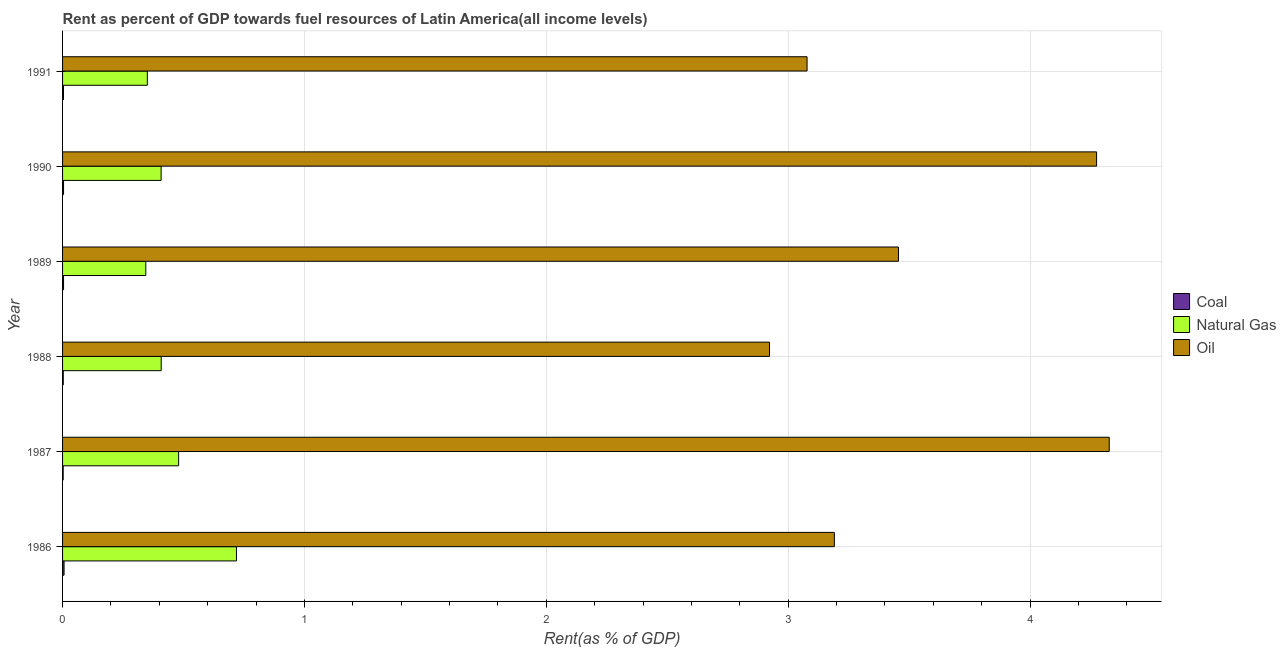How many groups of bars are there?
Provide a short and direct response. 6. Are the number of bars on each tick of the Y-axis equal?
Ensure brevity in your answer.  Yes. How many bars are there on the 6th tick from the top?
Your answer should be compact. 3. What is the label of the 5th group of bars from the top?
Provide a succinct answer. 1987. In how many cases, is the number of bars for a given year not equal to the number of legend labels?
Keep it short and to the point. 0. What is the rent towards natural gas in 1987?
Keep it short and to the point. 0.48. Across all years, what is the maximum rent towards oil?
Provide a short and direct response. 4.33. Across all years, what is the minimum rent towards coal?
Provide a short and direct response. 0. In which year was the rent towards oil maximum?
Your response must be concise. 1987. In which year was the rent towards natural gas minimum?
Keep it short and to the point. 1989. What is the total rent towards natural gas in the graph?
Make the answer very short. 2.71. What is the difference between the rent towards coal in 1988 and that in 1990?
Provide a short and direct response. -0. What is the difference between the rent towards coal in 1990 and the rent towards natural gas in 1987?
Make the answer very short. -0.48. What is the average rent towards natural gas per year?
Offer a terse response. 0.45. In the year 1991, what is the difference between the rent towards coal and rent towards oil?
Offer a terse response. -3.07. What is the ratio of the rent towards coal in 1987 to that in 1988?
Make the answer very short. 0.87. Is the difference between the rent towards natural gas in 1988 and 1991 greater than the difference between the rent towards coal in 1988 and 1991?
Keep it short and to the point. Yes. What is the difference between the highest and the second highest rent towards natural gas?
Your answer should be compact. 0.24. What is the difference between the highest and the lowest rent towards natural gas?
Give a very brief answer. 0.37. Is the sum of the rent towards natural gas in 1988 and 1990 greater than the maximum rent towards coal across all years?
Provide a succinct answer. Yes. What does the 2nd bar from the top in 1986 represents?
Offer a very short reply. Natural Gas. What does the 2nd bar from the bottom in 1991 represents?
Give a very brief answer. Natural Gas. Is it the case that in every year, the sum of the rent towards coal and rent towards natural gas is greater than the rent towards oil?
Give a very brief answer. No. Are all the bars in the graph horizontal?
Offer a terse response. Yes. How many years are there in the graph?
Offer a very short reply. 6. Are the values on the major ticks of X-axis written in scientific E-notation?
Provide a succinct answer. No. Does the graph contain any zero values?
Give a very brief answer. No. Does the graph contain grids?
Offer a terse response. Yes. How are the legend labels stacked?
Provide a succinct answer. Vertical. What is the title of the graph?
Your answer should be compact. Rent as percent of GDP towards fuel resources of Latin America(all income levels). Does "Grants" appear as one of the legend labels in the graph?
Offer a very short reply. No. What is the label or title of the X-axis?
Your answer should be compact. Rent(as % of GDP). What is the Rent(as % of GDP) in Coal in 1986?
Provide a succinct answer. 0.01. What is the Rent(as % of GDP) in Natural Gas in 1986?
Offer a terse response. 0.72. What is the Rent(as % of GDP) in Oil in 1986?
Ensure brevity in your answer.  3.19. What is the Rent(as % of GDP) of Coal in 1987?
Offer a very short reply. 0. What is the Rent(as % of GDP) in Natural Gas in 1987?
Give a very brief answer. 0.48. What is the Rent(as % of GDP) in Oil in 1987?
Keep it short and to the point. 4.33. What is the Rent(as % of GDP) in Coal in 1988?
Provide a succinct answer. 0. What is the Rent(as % of GDP) in Natural Gas in 1988?
Keep it short and to the point. 0.41. What is the Rent(as % of GDP) in Oil in 1988?
Offer a very short reply. 2.92. What is the Rent(as % of GDP) in Coal in 1989?
Your answer should be very brief. 0. What is the Rent(as % of GDP) of Natural Gas in 1989?
Offer a terse response. 0.34. What is the Rent(as % of GDP) of Oil in 1989?
Your answer should be compact. 3.46. What is the Rent(as % of GDP) in Coal in 1990?
Provide a short and direct response. 0. What is the Rent(as % of GDP) of Natural Gas in 1990?
Ensure brevity in your answer.  0.41. What is the Rent(as % of GDP) in Oil in 1990?
Make the answer very short. 4.28. What is the Rent(as % of GDP) in Coal in 1991?
Offer a very short reply. 0. What is the Rent(as % of GDP) of Natural Gas in 1991?
Offer a terse response. 0.35. What is the Rent(as % of GDP) in Oil in 1991?
Your answer should be very brief. 3.08. Across all years, what is the maximum Rent(as % of GDP) in Coal?
Provide a succinct answer. 0.01. Across all years, what is the maximum Rent(as % of GDP) in Natural Gas?
Keep it short and to the point. 0.72. Across all years, what is the maximum Rent(as % of GDP) of Oil?
Keep it short and to the point. 4.33. Across all years, what is the minimum Rent(as % of GDP) of Coal?
Your answer should be compact. 0. Across all years, what is the minimum Rent(as % of GDP) in Natural Gas?
Your answer should be very brief. 0.34. Across all years, what is the minimum Rent(as % of GDP) of Oil?
Provide a short and direct response. 2.92. What is the total Rent(as % of GDP) of Coal in the graph?
Your answer should be compact. 0.02. What is the total Rent(as % of GDP) in Natural Gas in the graph?
Your answer should be very brief. 2.71. What is the total Rent(as % of GDP) in Oil in the graph?
Your answer should be compact. 21.25. What is the difference between the Rent(as % of GDP) of Coal in 1986 and that in 1987?
Provide a short and direct response. 0. What is the difference between the Rent(as % of GDP) in Natural Gas in 1986 and that in 1987?
Provide a succinct answer. 0.24. What is the difference between the Rent(as % of GDP) in Oil in 1986 and that in 1987?
Provide a short and direct response. -1.14. What is the difference between the Rent(as % of GDP) of Coal in 1986 and that in 1988?
Provide a succinct answer. 0. What is the difference between the Rent(as % of GDP) in Natural Gas in 1986 and that in 1988?
Your answer should be very brief. 0.31. What is the difference between the Rent(as % of GDP) of Oil in 1986 and that in 1988?
Provide a succinct answer. 0.27. What is the difference between the Rent(as % of GDP) in Coal in 1986 and that in 1989?
Give a very brief answer. 0. What is the difference between the Rent(as % of GDP) in Natural Gas in 1986 and that in 1989?
Provide a short and direct response. 0.37. What is the difference between the Rent(as % of GDP) in Oil in 1986 and that in 1989?
Make the answer very short. -0.27. What is the difference between the Rent(as % of GDP) in Coal in 1986 and that in 1990?
Provide a succinct answer. 0. What is the difference between the Rent(as % of GDP) in Natural Gas in 1986 and that in 1990?
Offer a very short reply. 0.31. What is the difference between the Rent(as % of GDP) of Oil in 1986 and that in 1990?
Provide a short and direct response. -1.08. What is the difference between the Rent(as % of GDP) of Coal in 1986 and that in 1991?
Your answer should be compact. 0. What is the difference between the Rent(as % of GDP) of Natural Gas in 1986 and that in 1991?
Make the answer very short. 0.37. What is the difference between the Rent(as % of GDP) of Oil in 1986 and that in 1991?
Your answer should be compact. 0.11. What is the difference between the Rent(as % of GDP) of Coal in 1987 and that in 1988?
Ensure brevity in your answer.  -0. What is the difference between the Rent(as % of GDP) in Natural Gas in 1987 and that in 1988?
Give a very brief answer. 0.07. What is the difference between the Rent(as % of GDP) in Oil in 1987 and that in 1988?
Your answer should be very brief. 1.4. What is the difference between the Rent(as % of GDP) of Coal in 1987 and that in 1989?
Your response must be concise. -0. What is the difference between the Rent(as % of GDP) of Natural Gas in 1987 and that in 1989?
Your response must be concise. 0.14. What is the difference between the Rent(as % of GDP) in Oil in 1987 and that in 1989?
Your answer should be very brief. 0.87. What is the difference between the Rent(as % of GDP) in Coal in 1987 and that in 1990?
Ensure brevity in your answer.  -0. What is the difference between the Rent(as % of GDP) in Natural Gas in 1987 and that in 1990?
Your answer should be compact. 0.07. What is the difference between the Rent(as % of GDP) in Oil in 1987 and that in 1990?
Offer a terse response. 0.05. What is the difference between the Rent(as % of GDP) of Coal in 1987 and that in 1991?
Provide a short and direct response. -0. What is the difference between the Rent(as % of GDP) in Natural Gas in 1987 and that in 1991?
Offer a very short reply. 0.13. What is the difference between the Rent(as % of GDP) of Oil in 1987 and that in 1991?
Your answer should be very brief. 1.25. What is the difference between the Rent(as % of GDP) in Coal in 1988 and that in 1989?
Your response must be concise. -0. What is the difference between the Rent(as % of GDP) of Natural Gas in 1988 and that in 1989?
Provide a short and direct response. 0.06. What is the difference between the Rent(as % of GDP) in Oil in 1988 and that in 1989?
Offer a terse response. -0.53. What is the difference between the Rent(as % of GDP) in Coal in 1988 and that in 1990?
Offer a terse response. -0. What is the difference between the Rent(as % of GDP) of Natural Gas in 1988 and that in 1990?
Make the answer very short. 0. What is the difference between the Rent(as % of GDP) of Oil in 1988 and that in 1990?
Your answer should be compact. -1.35. What is the difference between the Rent(as % of GDP) of Coal in 1988 and that in 1991?
Offer a very short reply. -0. What is the difference between the Rent(as % of GDP) in Natural Gas in 1988 and that in 1991?
Provide a succinct answer. 0.06. What is the difference between the Rent(as % of GDP) in Oil in 1988 and that in 1991?
Keep it short and to the point. -0.16. What is the difference between the Rent(as % of GDP) of Natural Gas in 1989 and that in 1990?
Keep it short and to the point. -0.06. What is the difference between the Rent(as % of GDP) in Oil in 1989 and that in 1990?
Your answer should be compact. -0.82. What is the difference between the Rent(as % of GDP) in Natural Gas in 1989 and that in 1991?
Offer a very short reply. -0.01. What is the difference between the Rent(as % of GDP) of Oil in 1989 and that in 1991?
Ensure brevity in your answer.  0.38. What is the difference between the Rent(as % of GDP) of Natural Gas in 1990 and that in 1991?
Offer a terse response. 0.06. What is the difference between the Rent(as % of GDP) of Oil in 1990 and that in 1991?
Make the answer very short. 1.2. What is the difference between the Rent(as % of GDP) in Coal in 1986 and the Rent(as % of GDP) in Natural Gas in 1987?
Give a very brief answer. -0.47. What is the difference between the Rent(as % of GDP) in Coal in 1986 and the Rent(as % of GDP) in Oil in 1987?
Offer a very short reply. -4.32. What is the difference between the Rent(as % of GDP) of Natural Gas in 1986 and the Rent(as % of GDP) of Oil in 1987?
Offer a very short reply. -3.61. What is the difference between the Rent(as % of GDP) of Coal in 1986 and the Rent(as % of GDP) of Natural Gas in 1988?
Your answer should be very brief. -0.4. What is the difference between the Rent(as % of GDP) in Coal in 1986 and the Rent(as % of GDP) in Oil in 1988?
Offer a very short reply. -2.92. What is the difference between the Rent(as % of GDP) of Natural Gas in 1986 and the Rent(as % of GDP) of Oil in 1988?
Your answer should be very brief. -2.2. What is the difference between the Rent(as % of GDP) in Coal in 1986 and the Rent(as % of GDP) in Natural Gas in 1989?
Your response must be concise. -0.34. What is the difference between the Rent(as % of GDP) of Coal in 1986 and the Rent(as % of GDP) of Oil in 1989?
Your response must be concise. -3.45. What is the difference between the Rent(as % of GDP) of Natural Gas in 1986 and the Rent(as % of GDP) of Oil in 1989?
Ensure brevity in your answer.  -2.74. What is the difference between the Rent(as % of GDP) in Coal in 1986 and the Rent(as % of GDP) in Natural Gas in 1990?
Give a very brief answer. -0.4. What is the difference between the Rent(as % of GDP) of Coal in 1986 and the Rent(as % of GDP) of Oil in 1990?
Make the answer very short. -4.27. What is the difference between the Rent(as % of GDP) of Natural Gas in 1986 and the Rent(as % of GDP) of Oil in 1990?
Ensure brevity in your answer.  -3.56. What is the difference between the Rent(as % of GDP) of Coal in 1986 and the Rent(as % of GDP) of Natural Gas in 1991?
Make the answer very short. -0.34. What is the difference between the Rent(as % of GDP) of Coal in 1986 and the Rent(as % of GDP) of Oil in 1991?
Keep it short and to the point. -3.07. What is the difference between the Rent(as % of GDP) in Natural Gas in 1986 and the Rent(as % of GDP) in Oil in 1991?
Offer a very short reply. -2.36. What is the difference between the Rent(as % of GDP) in Coal in 1987 and the Rent(as % of GDP) in Natural Gas in 1988?
Your answer should be very brief. -0.41. What is the difference between the Rent(as % of GDP) in Coal in 1987 and the Rent(as % of GDP) in Oil in 1988?
Provide a succinct answer. -2.92. What is the difference between the Rent(as % of GDP) of Natural Gas in 1987 and the Rent(as % of GDP) of Oil in 1988?
Ensure brevity in your answer.  -2.44. What is the difference between the Rent(as % of GDP) of Coal in 1987 and the Rent(as % of GDP) of Natural Gas in 1989?
Your answer should be compact. -0.34. What is the difference between the Rent(as % of GDP) in Coal in 1987 and the Rent(as % of GDP) in Oil in 1989?
Ensure brevity in your answer.  -3.45. What is the difference between the Rent(as % of GDP) of Natural Gas in 1987 and the Rent(as % of GDP) of Oil in 1989?
Ensure brevity in your answer.  -2.98. What is the difference between the Rent(as % of GDP) of Coal in 1987 and the Rent(as % of GDP) of Natural Gas in 1990?
Offer a terse response. -0.41. What is the difference between the Rent(as % of GDP) of Coal in 1987 and the Rent(as % of GDP) of Oil in 1990?
Provide a short and direct response. -4.27. What is the difference between the Rent(as % of GDP) of Natural Gas in 1987 and the Rent(as % of GDP) of Oil in 1990?
Offer a very short reply. -3.8. What is the difference between the Rent(as % of GDP) of Coal in 1987 and the Rent(as % of GDP) of Natural Gas in 1991?
Your answer should be very brief. -0.35. What is the difference between the Rent(as % of GDP) in Coal in 1987 and the Rent(as % of GDP) in Oil in 1991?
Make the answer very short. -3.08. What is the difference between the Rent(as % of GDP) of Natural Gas in 1987 and the Rent(as % of GDP) of Oil in 1991?
Ensure brevity in your answer.  -2.6. What is the difference between the Rent(as % of GDP) in Coal in 1988 and the Rent(as % of GDP) in Natural Gas in 1989?
Make the answer very short. -0.34. What is the difference between the Rent(as % of GDP) of Coal in 1988 and the Rent(as % of GDP) of Oil in 1989?
Ensure brevity in your answer.  -3.45. What is the difference between the Rent(as % of GDP) of Natural Gas in 1988 and the Rent(as % of GDP) of Oil in 1989?
Your answer should be compact. -3.05. What is the difference between the Rent(as % of GDP) of Coal in 1988 and the Rent(as % of GDP) of Natural Gas in 1990?
Your answer should be compact. -0.4. What is the difference between the Rent(as % of GDP) of Coal in 1988 and the Rent(as % of GDP) of Oil in 1990?
Provide a short and direct response. -4.27. What is the difference between the Rent(as % of GDP) of Natural Gas in 1988 and the Rent(as % of GDP) of Oil in 1990?
Make the answer very short. -3.87. What is the difference between the Rent(as % of GDP) of Coal in 1988 and the Rent(as % of GDP) of Natural Gas in 1991?
Offer a very short reply. -0.35. What is the difference between the Rent(as % of GDP) of Coal in 1988 and the Rent(as % of GDP) of Oil in 1991?
Your answer should be very brief. -3.08. What is the difference between the Rent(as % of GDP) of Natural Gas in 1988 and the Rent(as % of GDP) of Oil in 1991?
Offer a very short reply. -2.67. What is the difference between the Rent(as % of GDP) of Coal in 1989 and the Rent(as % of GDP) of Natural Gas in 1990?
Offer a very short reply. -0.4. What is the difference between the Rent(as % of GDP) of Coal in 1989 and the Rent(as % of GDP) of Oil in 1990?
Keep it short and to the point. -4.27. What is the difference between the Rent(as % of GDP) in Natural Gas in 1989 and the Rent(as % of GDP) in Oil in 1990?
Provide a succinct answer. -3.93. What is the difference between the Rent(as % of GDP) in Coal in 1989 and the Rent(as % of GDP) in Natural Gas in 1991?
Your answer should be very brief. -0.35. What is the difference between the Rent(as % of GDP) of Coal in 1989 and the Rent(as % of GDP) of Oil in 1991?
Offer a terse response. -3.07. What is the difference between the Rent(as % of GDP) of Natural Gas in 1989 and the Rent(as % of GDP) of Oil in 1991?
Give a very brief answer. -2.73. What is the difference between the Rent(as % of GDP) in Coal in 1990 and the Rent(as % of GDP) in Natural Gas in 1991?
Your answer should be very brief. -0.35. What is the difference between the Rent(as % of GDP) in Coal in 1990 and the Rent(as % of GDP) in Oil in 1991?
Offer a very short reply. -3.07. What is the difference between the Rent(as % of GDP) in Natural Gas in 1990 and the Rent(as % of GDP) in Oil in 1991?
Give a very brief answer. -2.67. What is the average Rent(as % of GDP) of Coal per year?
Give a very brief answer. 0. What is the average Rent(as % of GDP) in Natural Gas per year?
Provide a succinct answer. 0.45. What is the average Rent(as % of GDP) in Oil per year?
Your answer should be very brief. 3.54. In the year 1986, what is the difference between the Rent(as % of GDP) in Coal and Rent(as % of GDP) in Natural Gas?
Provide a succinct answer. -0.71. In the year 1986, what is the difference between the Rent(as % of GDP) of Coal and Rent(as % of GDP) of Oil?
Make the answer very short. -3.18. In the year 1986, what is the difference between the Rent(as % of GDP) in Natural Gas and Rent(as % of GDP) in Oil?
Provide a succinct answer. -2.47. In the year 1987, what is the difference between the Rent(as % of GDP) in Coal and Rent(as % of GDP) in Natural Gas?
Make the answer very short. -0.48. In the year 1987, what is the difference between the Rent(as % of GDP) in Coal and Rent(as % of GDP) in Oil?
Your response must be concise. -4.33. In the year 1987, what is the difference between the Rent(as % of GDP) of Natural Gas and Rent(as % of GDP) of Oil?
Your answer should be very brief. -3.85. In the year 1988, what is the difference between the Rent(as % of GDP) in Coal and Rent(as % of GDP) in Natural Gas?
Give a very brief answer. -0.41. In the year 1988, what is the difference between the Rent(as % of GDP) in Coal and Rent(as % of GDP) in Oil?
Provide a succinct answer. -2.92. In the year 1988, what is the difference between the Rent(as % of GDP) in Natural Gas and Rent(as % of GDP) in Oil?
Offer a very short reply. -2.52. In the year 1989, what is the difference between the Rent(as % of GDP) in Coal and Rent(as % of GDP) in Natural Gas?
Keep it short and to the point. -0.34. In the year 1989, what is the difference between the Rent(as % of GDP) in Coal and Rent(as % of GDP) in Oil?
Offer a very short reply. -3.45. In the year 1989, what is the difference between the Rent(as % of GDP) in Natural Gas and Rent(as % of GDP) in Oil?
Give a very brief answer. -3.11. In the year 1990, what is the difference between the Rent(as % of GDP) of Coal and Rent(as % of GDP) of Natural Gas?
Give a very brief answer. -0.4. In the year 1990, what is the difference between the Rent(as % of GDP) of Coal and Rent(as % of GDP) of Oil?
Make the answer very short. -4.27. In the year 1990, what is the difference between the Rent(as % of GDP) of Natural Gas and Rent(as % of GDP) of Oil?
Make the answer very short. -3.87. In the year 1991, what is the difference between the Rent(as % of GDP) in Coal and Rent(as % of GDP) in Natural Gas?
Provide a short and direct response. -0.35. In the year 1991, what is the difference between the Rent(as % of GDP) of Coal and Rent(as % of GDP) of Oil?
Ensure brevity in your answer.  -3.07. In the year 1991, what is the difference between the Rent(as % of GDP) of Natural Gas and Rent(as % of GDP) of Oil?
Keep it short and to the point. -2.73. What is the ratio of the Rent(as % of GDP) of Coal in 1986 to that in 1987?
Provide a succinct answer. 2.48. What is the ratio of the Rent(as % of GDP) of Natural Gas in 1986 to that in 1987?
Ensure brevity in your answer.  1.5. What is the ratio of the Rent(as % of GDP) in Oil in 1986 to that in 1987?
Make the answer very short. 0.74. What is the ratio of the Rent(as % of GDP) in Coal in 1986 to that in 1988?
Give a very brief answer. 2.17. What is the ratio of the Rent(as % of GDP) in Natural Gas in 1986 to that in 1988?
Keep it short and to the point. 1.76. What is the ratio of the Rent(as % of GDP) of Oil in 1986 to that in 1988?
Provide a succinct answer. 1.09. What is the ratio of the Rent(as % of GDP) in Coal in 1986 to that in 1989?
Keep it short and to the point. 1.52. What is the ratio of the Rent(as % of GDP) in Natural Gas in 1986 to that in 1989?
Ensure brevity in your answer.  2.09. What is the ratio of the Rent(as % of GDP) in Oil in 1986 to that in 1989?
Keep it short and to the point. 0.92. What is the ratio of the Rent(as % of GDP) of Coal in 1986 to that in 1990?
Provide a short and direct response. 1.52. What is the ratio of the Rent(as % of GDP) of Natural Gas in 1986 to that in 1990?
Your answer should be compact. 1.76. What is the ratio of the Rent(as % of GDP) in Oil in 1986 to that in 1990?
Ensure brevity in your answer.  0.75. What is the ratio of the Rent(as % of GDP) of Coal in 1986 to that in 1991?
Offer a terse response. 1.63. What is the ratio of the Rent(as % of GDP) of Natural Gas in 1986 to that in 1991?
Your response must be concise. 2.05. What is the ratio of the Rent(as % of GDP) of Oil in 1986 to that in 1991?
Keep it short and to the point. 1.04. What is the ratio of the Rent(as % of GDP) in Coal in 1987 to that in 1988?
Your answer should be compact. 0.87. What is the ratio of the Rent(as % of GDP) of Natural Gas in 1987 to that in 1988?
Provide a short and direct response. 1.18. What is the ratio of the Rent(as % of GDP) in Oil in 1987 to that in 1988?
Your answer should be compact. 1.48. What is the ratio of the Rent(as % of GDP) in Coal in 1987 to that in 1989?
Make the answer very short. 0.61. What is the ratio of the Rent(as % of GDP) in Natural Gas in 1987 to that in 1989?
Your answer should be compact. 1.39. What is the ratio of the Rent(as % of GDP) of Oil in 1987 to that in 1989?
Offer a very short reply. 1.25. What is the ratio of the Rent(as % of GDP) in Coal in 1987 to that in 1990?
Your answer should be compact. 0.61. What is the ratio of the Rent(as % of GDP) in Natural Gas in 1987 to that in 1990?
Ensure brevity in your answer.  1.18. What is the ratio of the Rent(as % of GDP) of Oil in 1987 to that in 1990?
Keep it short and to the point. 1.01. What is the ratio of the Rent(as % of GDP) of Coal in 1987 to that in 1991?
Ensure brevity in your answer.  0.66. What is the ratio of the Rent(as % of GDP) in Natural Gas in 1987 to that in 1991?
Keep it short and to the point. 1.37. What is the ratio of the Rent(as % of GDP) in Oil in 1987 to that in 1991?
Provide a succinct answer. 1.41. What is the ratio of the Rent(as % of GDP) of Coal in 1988 to that in 1989?
Make the answer very short. 0.7. What is the ratio of the Rent(as % of GDP) in Natural Gas in 1988 to that in 1989?
Give a very brief answer. 1.19. What is the ratio of the Rent(as % of GDP) of Oil in 1988 to that in 1989?
Provide a short and direct response. 0.85. What is the ratio of the Rent(as % of GDP) of Coal in 1988 to that in 1990?
Give a very brief answer. 0.7. What is the ratio of the Rent(as % of GDP) in Oil in 1988 to that in 1990?
Provide a short and direct response. 0.68. What is the ratio of the Rent(as % of GDP) of Coal in 1988 to that in 1991?
Ensure brevity in your answer.  0.75. What is the ratio of the Rent(as % of GDP) in Natural Gas in 1988 to that in 1991?
Provide a short and direct response. 1.16. What is the ratio of the Rent(as % of GDP) of Oil in 1988 to that in 1991?
Ensure brevity in your answer.  0.95. What is the ratio of the Rent(as % of GDP) in Coal in 1989 to that in 1990?
Offer a very short reply. 1. What is the ratio of the Rent(as % of GDP) of Natural Gas in 1989 to that in 1990?
Keep it short and to the point. 0.84. What is the ratio of the Rent(as % of GDP) in Oil in 1989 to that in 1990?
Provide a short and direct response. 0.81. What is the ratio of the Rent(as % of GDP) in Coal in 1989 to that in 1991?
Make the answer very short. 1.07. What is the ratio of the Rent(as % of GDP) of Natural Gas in 1989 to that in 1991?
Offer a very short reply. 0.98. What is the ratio of the Rent(as % of GDP) in Oil in 1989 to that in 1991?
Keep it short and to the point. 1.12. What is the ratio of the Rent(as % of GDP) of Coal in 1990 to that in 1991?
Your response must be concise. 1.07. What is the ratio of the Rent(as % of GDP) in Natural Gas in 1990 to that in 1991?
Ensure brevity in your answer.  1.16. What is the ratio of the Rent(as % of GDP) in Oil in 1990 to that in 1991?
Provide a short and direct response. 1.39. What is the difference between the highest and the second highest Rent(as % of GDP) of Coal?
Offer a terse response. 0. What is the difference between the highest and the second highest Rent(as % of GDP) of Natural Gas?
Make the answer very short. 0.24. What is the difference between the highest and the second highest Rent(as % of GDP) in Oil?
Offer a terse response. 0.05. What is the difference between the highest and the lowest Rent(as % of GDP) of Coal?
Your answer should be very brief. 0. What is the difference between the highest and the lowest Rent(as % of GDP) in Natural Gas?
Make the answer very short. 0.37. What is the difference between the highest and the lowest Rent(as % of GDP) in Oil?
Provide a succinct answer. 1.4. 